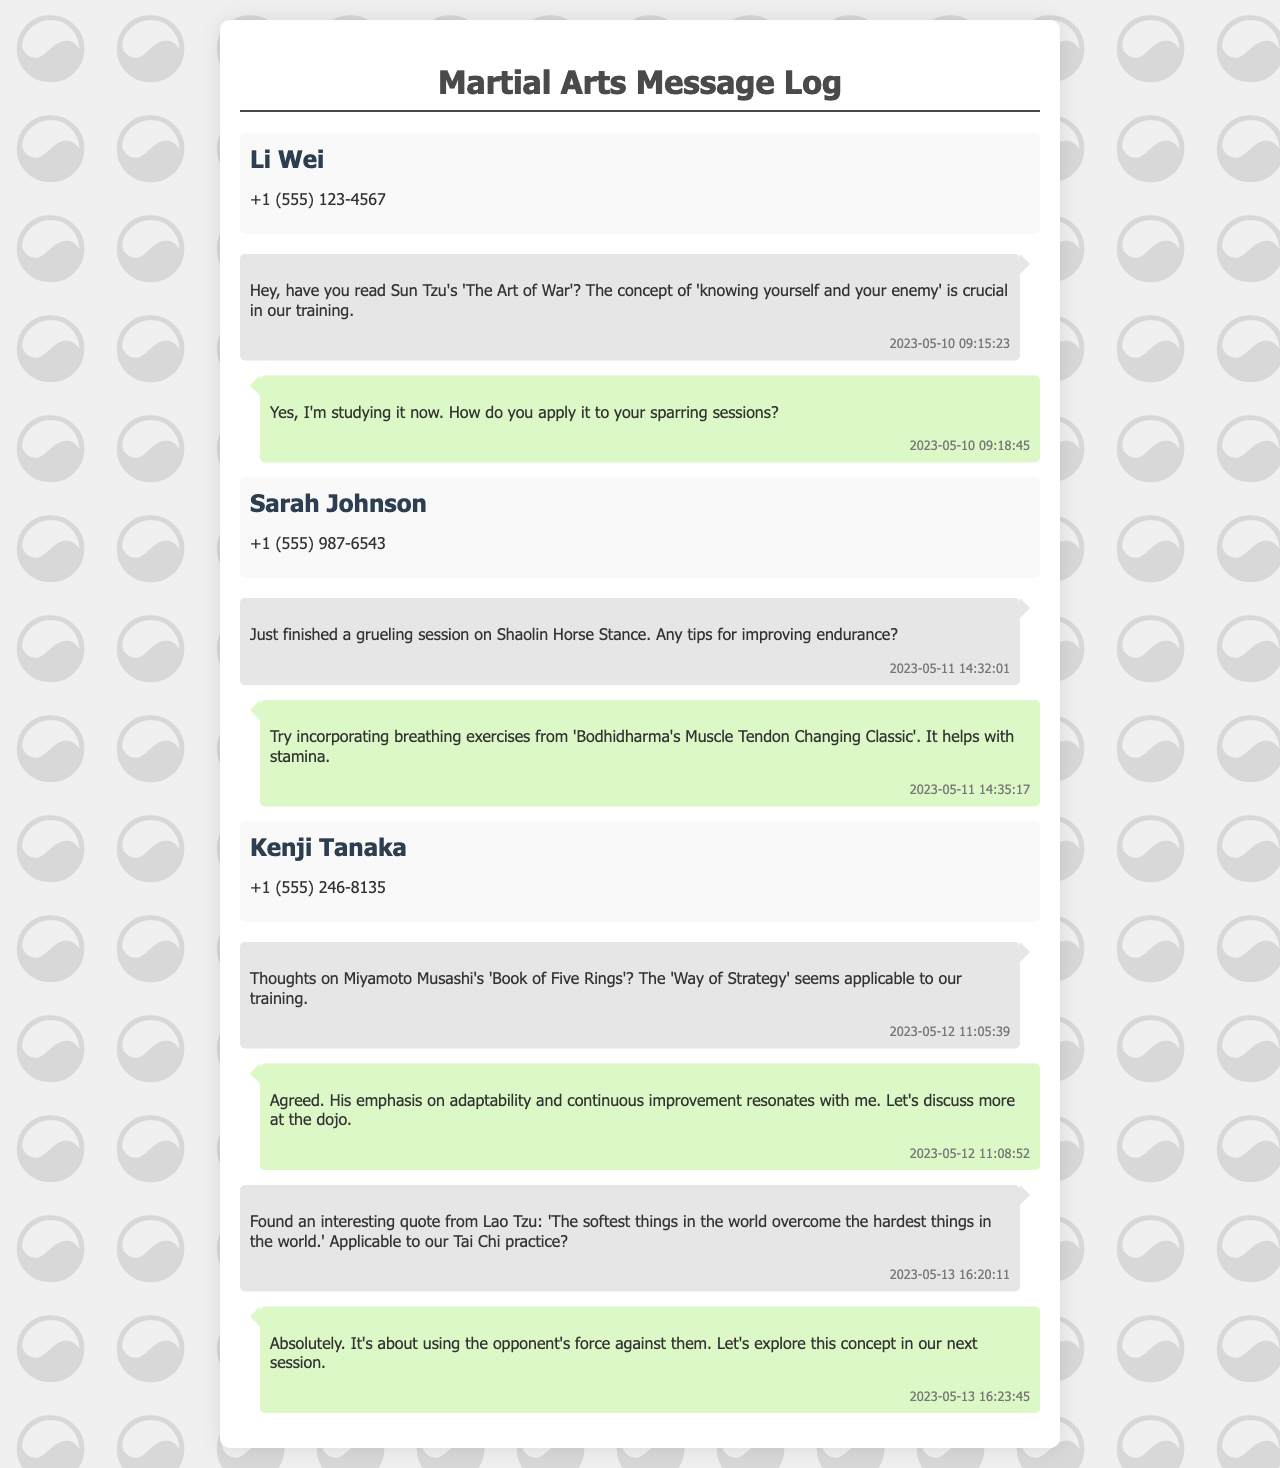What is the title of Sun Tzu's work mentioned? The document references 'The Art of War' as the work of Sun Tzu that is discussed.
Answer: 'The Art of War' Who sent the message about the Shaolin Horse Stance? The message about the Shaolin Horse Stance was received from Sarah Johnson.
Answer: Sarah Johnson What breathing exercise is recommended for improving endurance? The document refers to 'Bodhidharma's Muscle Tendon Changing Classic' as a source for breathing exercises.
Answer: 'Bodhidharma's Muscle Tendon Changing Classic' What is the main subject of Kenji's message received on May 12? Kenji Tanaka's message discusses thoughts on 'Book of Five Rings' by Miyamoto Musashi, particularly the 'Way of Strategy'.
Answer: 'Book of Five Rings' What concept from Lao Tzu is mentioned in relation to Tai Chi? The message refers to the quote about 'the softest things overcoming the hardest things' from Lao Tzu as applicable to Tai Chi.
Answer: 'The softest things in the world overcome the hardest things in the world' Who suggested discussing Musashi's works further at the dojo? The suggestion to discuss Musashi's work further at the dojo comes from the message sender in response to Kenji's inquiry.
Answer: The sender (you) 